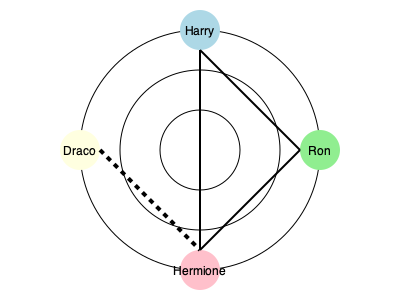In this node-link diagram representing character relationships in Harry Potter fanfiction, which character has the highest degree centrality, and what insight does this provide about fanfiction writing trends? To answer this question, we need to follow these steps:

1. Understand degree centrality: In network analysis, degree centrality is the number of direct connections a node has to other nodes.

2. Count connections for each character:
   - Harry: 2 connections (Ron and Hermione)
   - Ron: 2 connections (Harry and Hermione)
   - Hermione: 3 connections (Harry, Ron, and Draco)
   - Draco: 1 connection (Hermione)

3. Identify the character with the highest degree centrality:
   Hermione has the highest degree centrality with 3 connections.

4. Interpret the result in context of fanfiction trends:
   - Hermione's central position suggests she's a popular character in fanfiction narratives.
   - Her connection to Draco (represented by a dashed line) indicates a non-canonical relationship frequently explored in fanfiction.
   - This centrality reflects a trend in fanfiction to expand on Hermione's role and relationships beyond the original canon.

5. Conclusion:
   Hermione's high degree centrality in this network suggests that fanfiction writers tend to focus on her character, exploring both canonical and non-canonical relationships. This trend demonstrates how fanfiction communities often amplify or reinterpret secondary characters, contributing to the evolution of storytelling in the fandom.
Answer: Hermione; indicates focus on secondary character development and non-canonical relationships in fanfiction. 